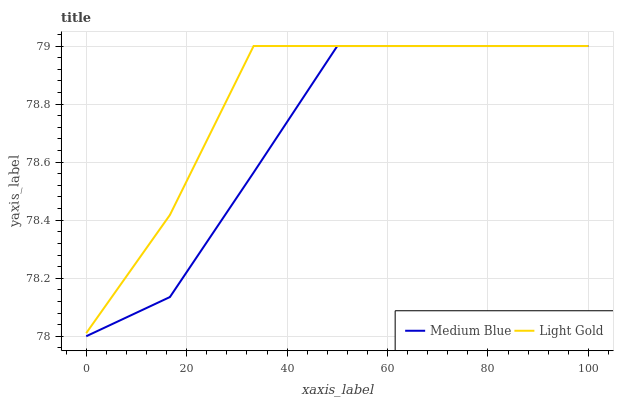Does Medium Blue have the minimum area under the curve?
Answer yes or no. Yes. Does Light Gold have the maximum area under the curve?
Answer yes or no. Yes. Does Medium Blue have the maximum area under the curve?
Answer yes or no. No. Is Medium Blue the smoothest?
Answer yes or no. Yes. Is Light Gold the roughest?
Answer yes or no. Yes. Is Medium Blue the roughest?
Answer yes or no. No. Does Medium Blue have the lowest value?
Answer yes or no. Yes. Does Medium Blue have the highest value?
Answer yes or no. Yes. Does Light Gold intersect Medium Blue?
Answer yes or no. Yes. Is Light Gold less than Medium Blue?
Answer yes or no. No. Is Light Gold greater than Medium Blue?
Answer yes or no. No. 